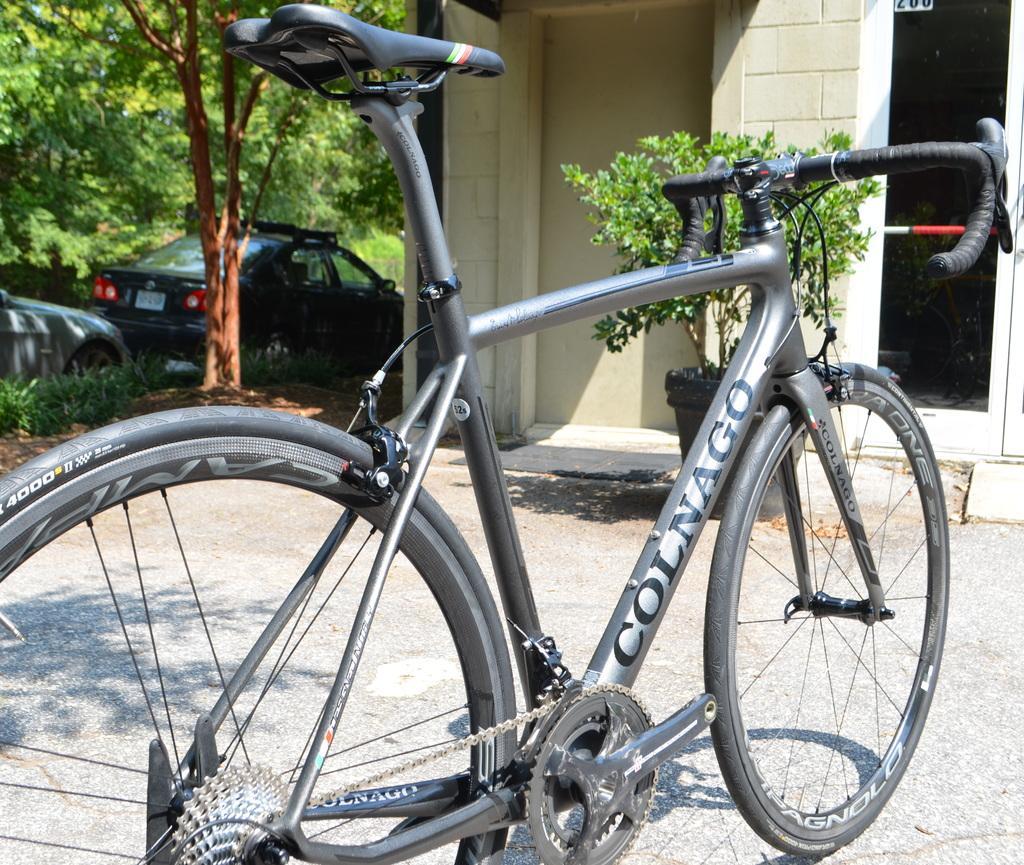Could you give a brief overview of what you see in this image? In this image we can see a bicycle which is placed on the ground. We can also see a building, a plant in a pot, some cars parked aside, plants and a group of trees. 